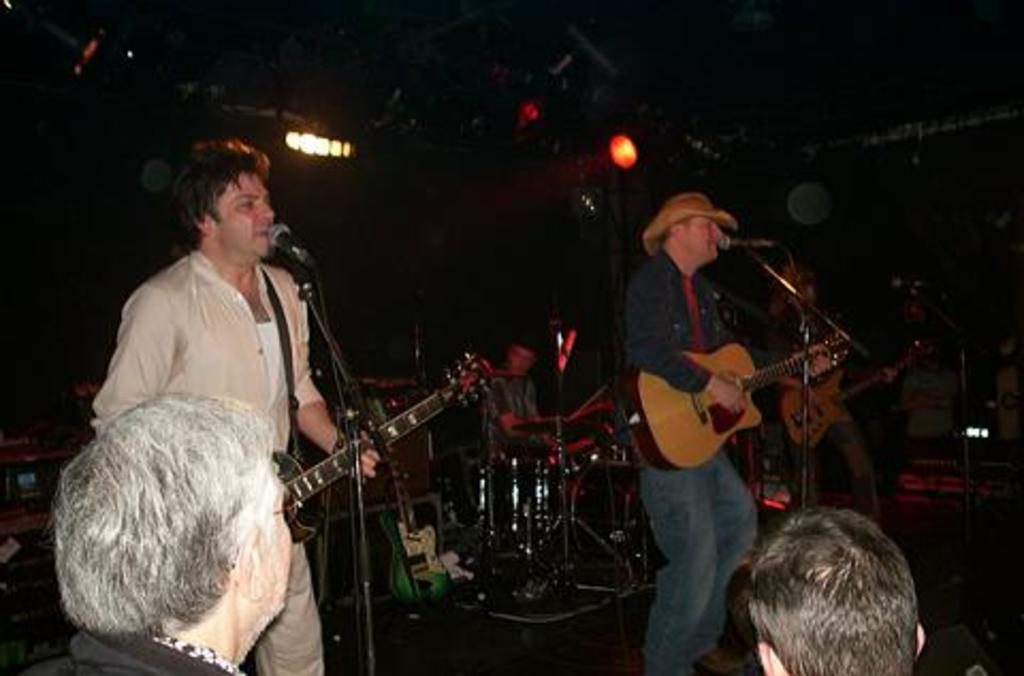What is happening in the image involving a group of people? The group of people are playing musical instruments. What can be seen in the background of the image? There are lights visible in the background of the image. What type of glue is being used by the writer in the image? There is no writer or glue present in the image; it features a group of people playing musical instruments. 